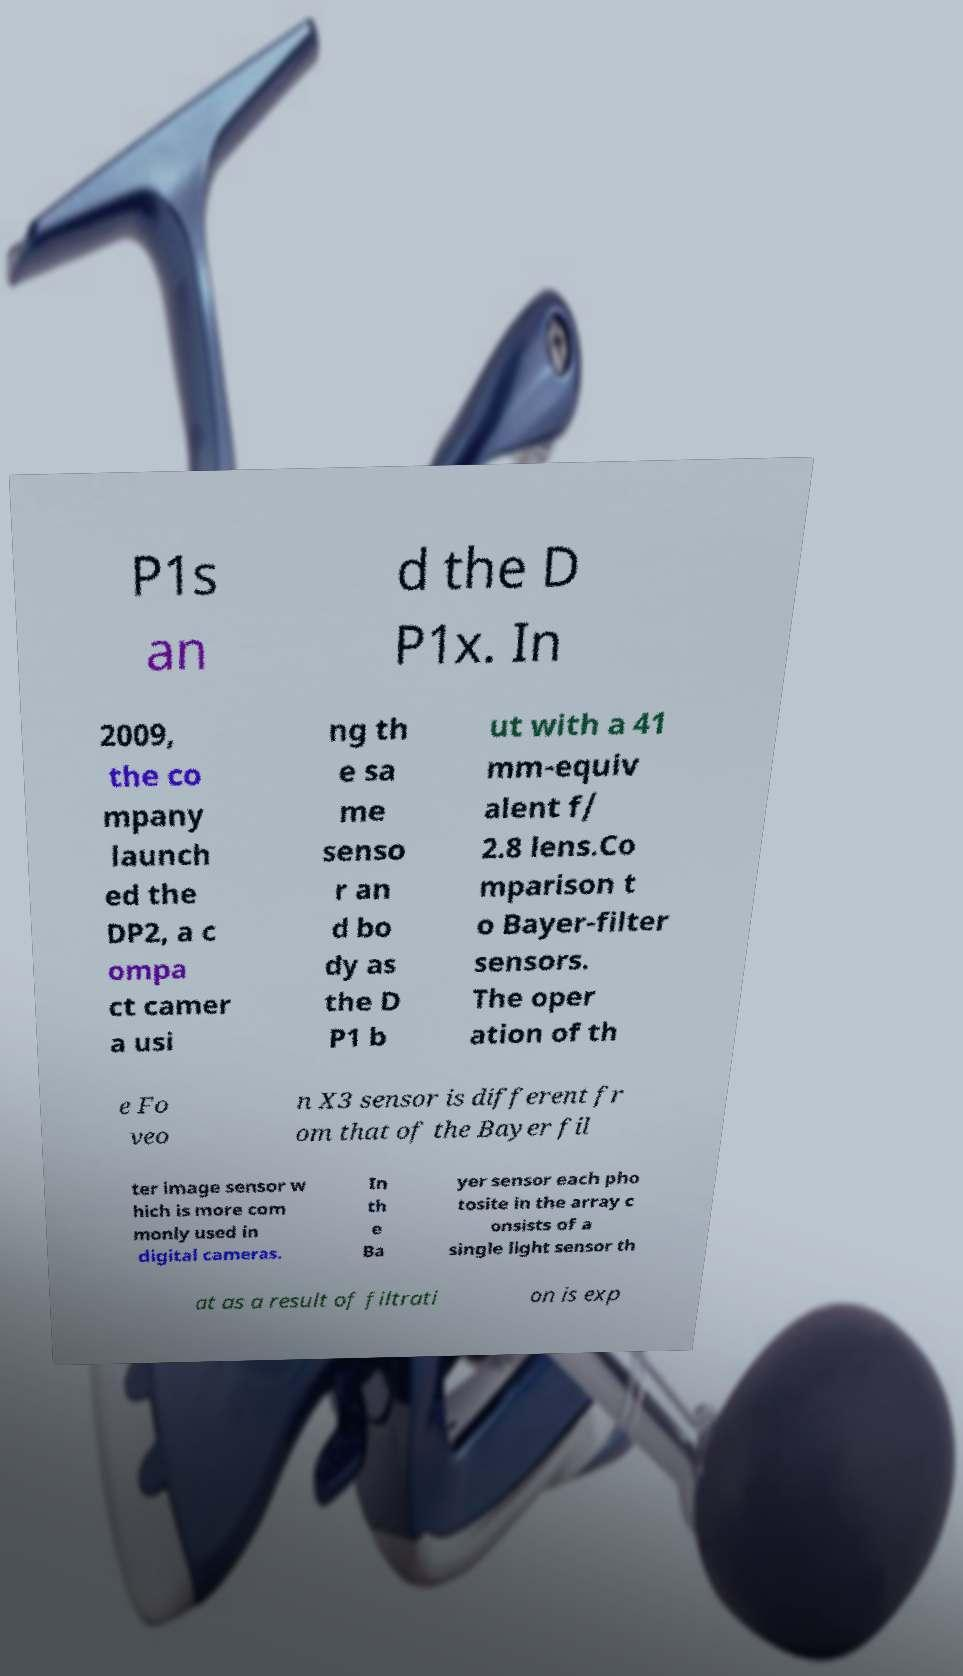I need the written content from this picture converted into text. Can you do that? P1s an d the D P1x. In 2009, the co mpany launch ed the DP2, a c ompa ct camer a usi ng th e sa me senso r an d bo dy as the D P1 b ut with a 41 mm-equiv alent f/ 2.8 lens.Co mparison t o Bayer-filter sensors. The oper ation of th e Fo veo n X3 sensor is different fr om that of the Bayer fil ter image sensor w hich is more com monly used in digital cameras. In th e Ba yer sensor each pho tosite in the array c onsists of a single light sensor th at as a result of filtrati on is exp 